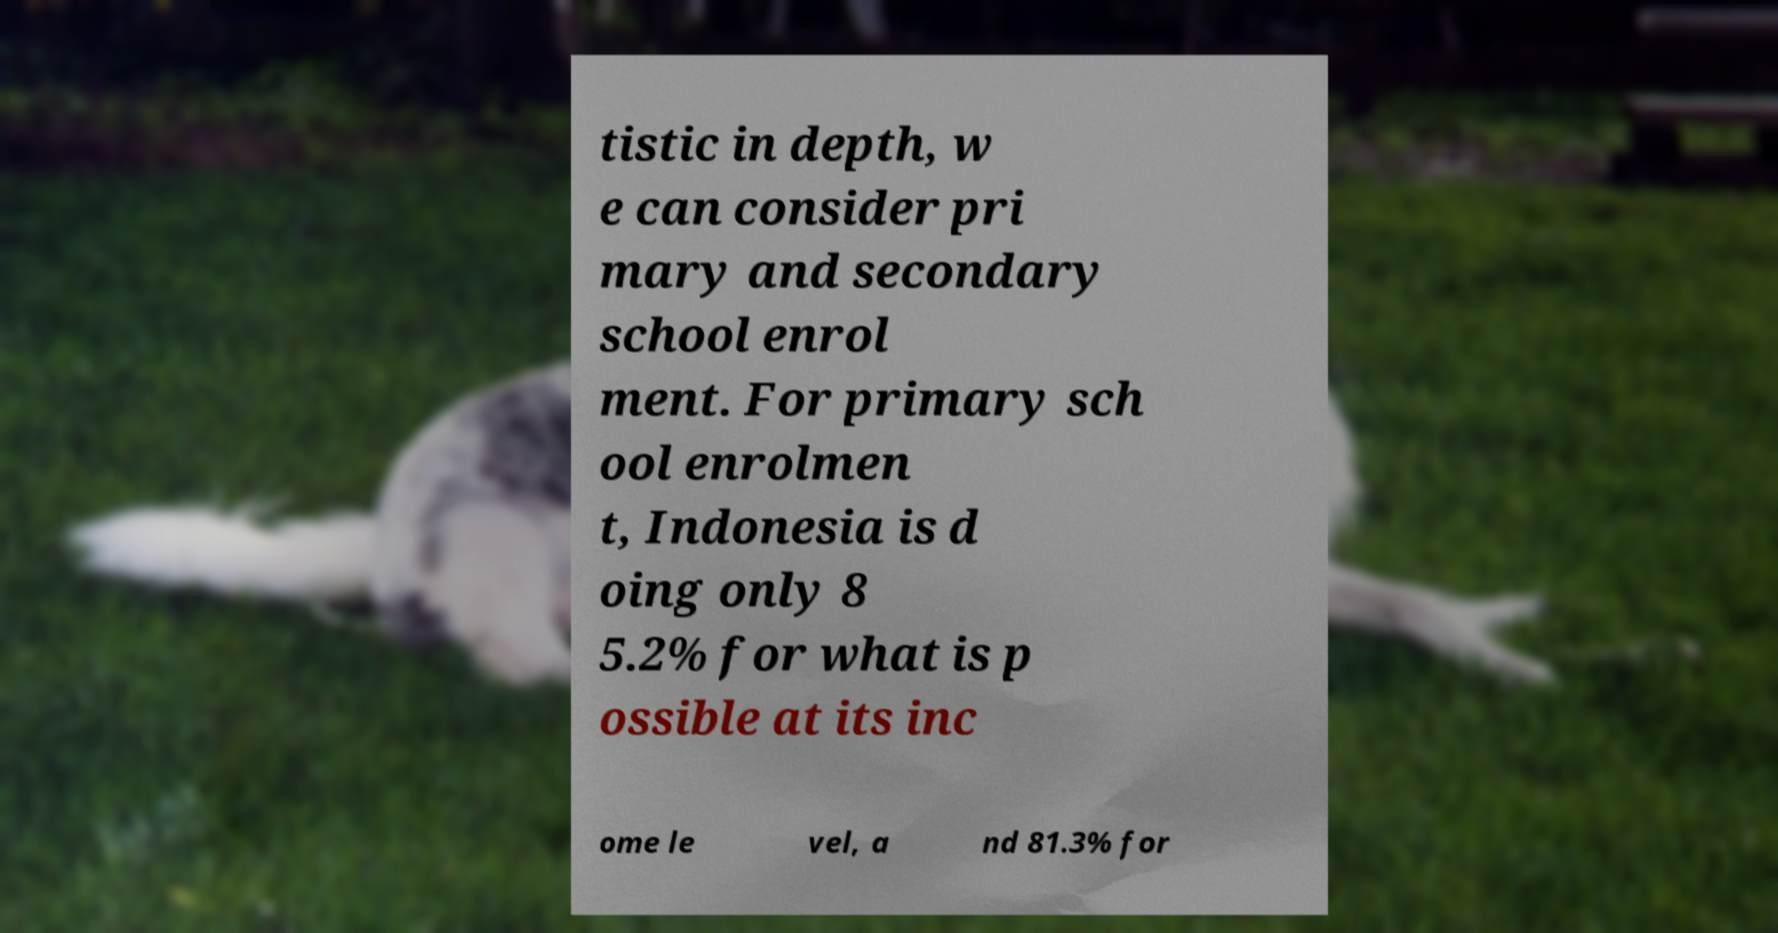Please read and relay the text visible in this image. What does it say? tistic in depth, w e can consider pri mary and secondary school enrol ment. For primary sch ool enrolmen t, Indonesia is d oing only 8 5.2% for what is p ossible at its inc ome le vel, a nd 81.3% for 